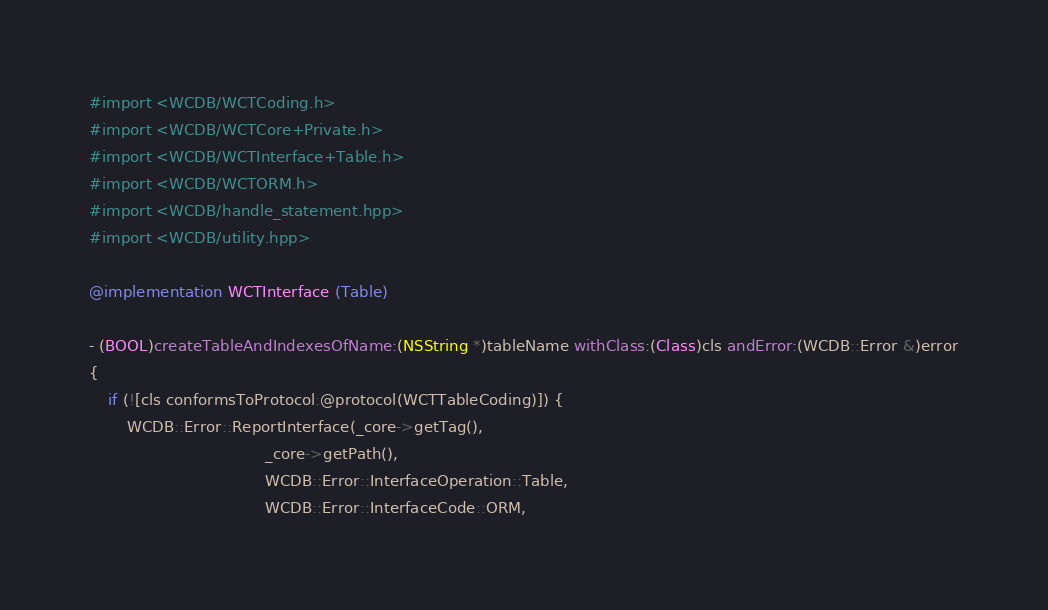<code> <loc_0><loc_0><loc_500><loc_500><_ObjectiveC_>
#import <WCDB/WCTCoding.h>
#import <WCDB/WCTCore+Private.h>
#import <WCDB/WCTInterface+Table.h>
#import <WCDB/WCTORM.h>
#import <WCDB/handle_statement.hpp>
#import <WCDB/utility.hpp>

@implementation WCTInterface (Table)

- (BOOL)createTableAndIndexesOfName:(NSString *)tableName withClass:(Class)cls andError:(WCDB::Error &)error
{
    if (![cls conformsToProtocol:@protocol(WCTTableCoding)]) {
        WCDB::Error::ReportInterface(_core->getTag(),
                                     _core->getPath(),
                                     WCDB::Error::InterfaceOperation::Table,
                                     WCDB::Error::InterfaceCode::ORM,</code> 